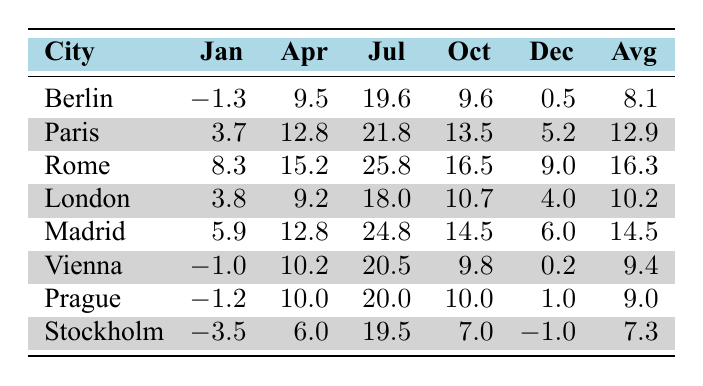What is the average temperature in Rome? To find the average temperature, we sum the monthly temperatures: (8.3 + 15.2 + 25.8 + 16.5 + 9.0 + 19.1 + 23.0 + 25.8 + 21.4 + 16.5 + 11.2 + 9.0) = 16.3 degrees. Since there are 12 months, we find the average by dividing this total by 12, resulting in an average of 16.3 degrees.
Answer: 16.3 Which city has the highest temperature in July? Looking at the July temperatures across all cities, we find the following: Berlin (19.6), Paris (21.8), Rome (25.8), London (18.0), Madrid (24.8), Vienna (20.5), Prague (20.0), and Stockholm (19.5). The highest among these is Rome with 25.8 degrees.
Answer: Rome Is the average temperature in Vienna higher than in Stockholm? First, we calculate the average temperatures: Vienna's total is (−1.0 + 0.4 + 5.2 + 10.2 + 15.2 + 18.6 + 20.5 + 19.8 + 14.6 + 9.8 + 4.3 + 0.2) = 9.4, and Stockholm's total is (−3.5 + -2.0 + 1.5 + 6.0 + 11.0 + 16.0 + 19.5 + 18.0 + 13.5 + 7.0 + 2.0 - 1.0) = 7.3. Comparing these averages shows 9.4 > 7.3, thus Vienna's average is higher.
Answer: Yes What is the temperature difference between January in Berlin and January in Madrid? Berlin's January temperature is -1.3 degrees, and Madrid's is 5.9 degrees. To find the temperature difference, we calculate: 5.9 - (-1.3) = 5.9 + 1.3 = 7.2 degrees.
Answer: 7.2 Which city experiences the coldest temperature in December? Reviewing the December temperatures shows: Berlin (0.5), Paris (5.2), Rome (9.0), London (4.0), Madrid (6.0), Vienna (0.2), Prague (1.0), and Stockholm (-1.0). The lowest temperature is -1.0 degrees in Stockholm.
Answer: Stockholm Is the temperature in Paris higher in October than in November? Paris has an October temperature of 13.5 degrees and a November temperature of 8.8 degrees. Since 13.5 > 8.8, October is indeed warmer than November in Paris.
Answer: Yes How many cities have an average temperature above 10 degrees? Calculating the average temperatures, we find: Berlin (8.1), Paris (12.9), Rome (16.3), London (10.2), Madrid (14.5), Vienna (9.4), Prague (9.0), and Stockholm (7.3). The cities above 10 degrees are Paris, Rome, London, and Madrid. Thus, there are four cities.
Answer: 4 What is the temperature in Prague for March? The table indicates that Prague's temperature in March is 4.5 degrees.
Answer: 4.5 Which city had the lowest temperature in January among all listed? Checking January temperatures: Berlin (-1.3), Paris (3.7), Rome (8.3), London (3.8), Madrid (5.9), Vienna (-1.0), Prague (-1.2), and Stockholm (-3.5). The lowest recorded temperature is -3.5 degrees in Stockholm.
Answer: Stockholm 